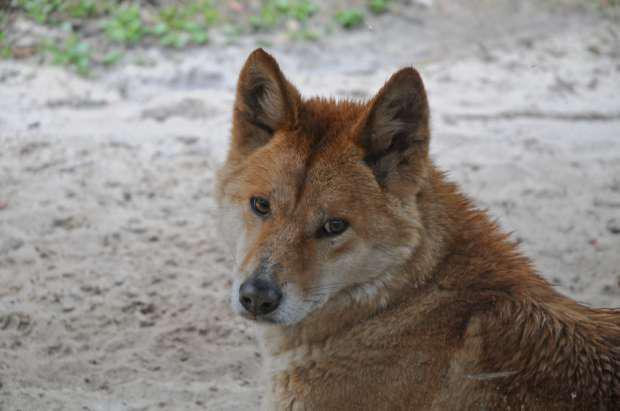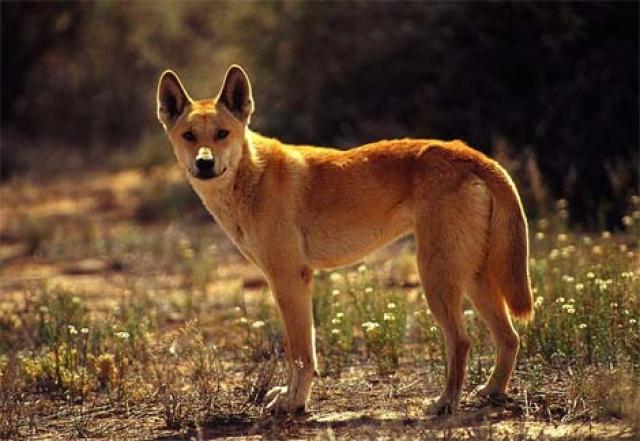The first image is the image on the left, the second image is the image on the right. Examine the images to the left and right. Is the description "at lest one dog is showing its teeth" accurate? Answer yes or no. No. 